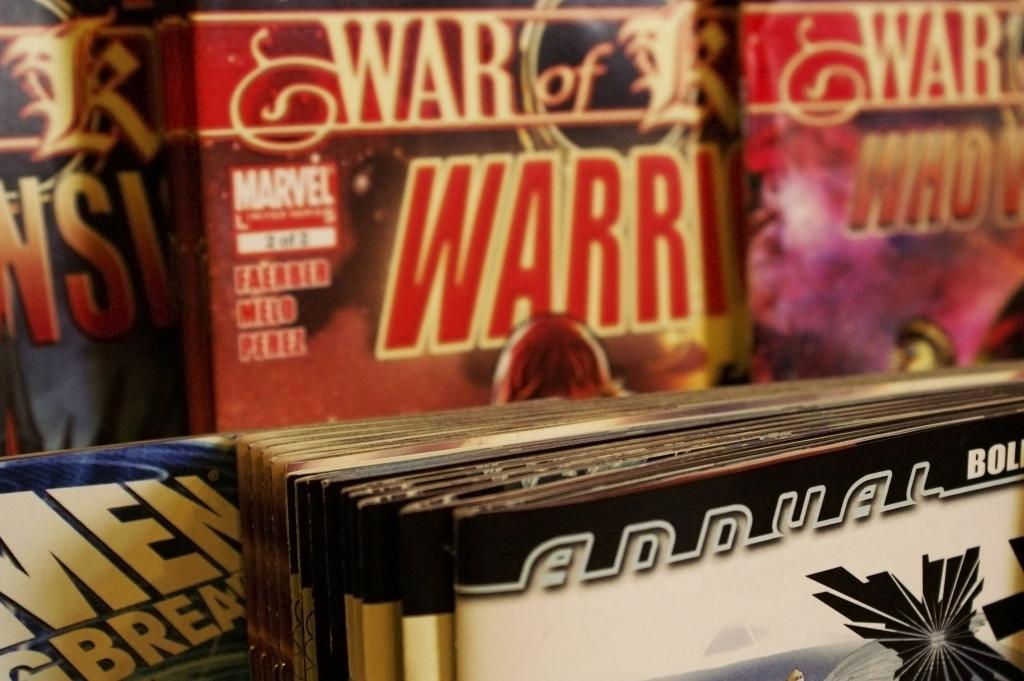<image>
Render a clear and concise summary of the photo. Several comic books in a stack with a title of War of WARRI. 